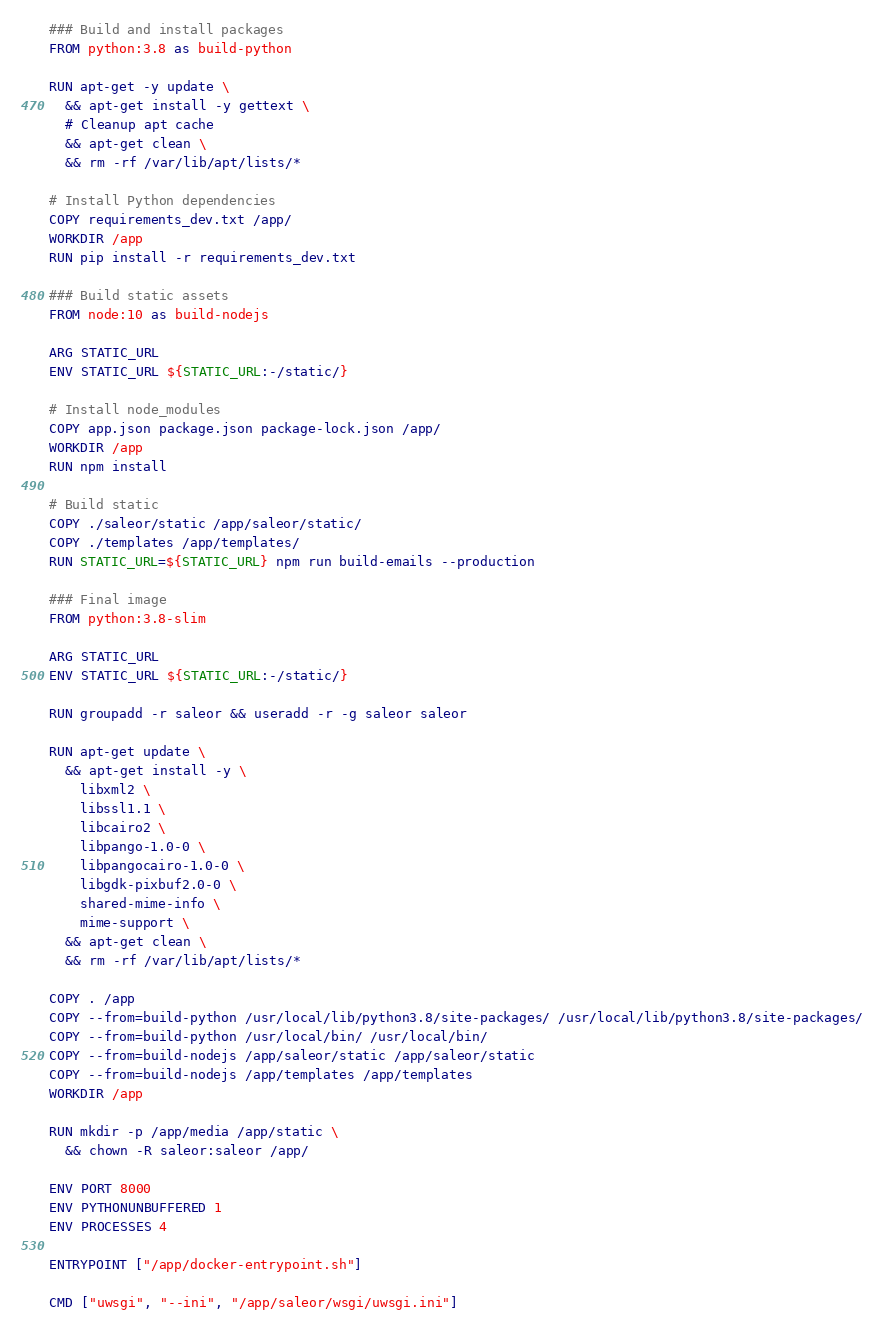<code> <loc_0><loc_0><loc_500><loc_500><_Dockerfile_>### Build and install packages
FROM python:3.8 as build-python

RUN apt-get -y update \
  && apt-get install -y gettext \
  # Cleanup apt cache
  && apt-get clean \
  && rm -rf /var/lib/apt/lists/*

# Install Python dependencies
COPY requirements_dev.txt /app/
WORKDIR /app
RUN pip install -r requirements_dev.txt

### Build static assets
FROM node:10 as build-nodejs

ARG STATIC_URL
ENV STATIC_URL ${STATIC_URL:-/static/}

# Install node_modules
COPY app.json package.json package-lock.json /app/
WORKDIR /app
RUN npm install

# Build static
COPY ./saleor/static /app/saleor/static/
COPY ./templates /app/templates/
RUN STATIC_URL=${STATIC_URL} npm run build-emails --production

### Final image
FROM python:3.8-slim

ARG STATIC_URL
ENV STATIC_URL ${STATIC_URL:-/static/}

RUN groupadd -r saleor && useradd -r -g saleor saleor

RUN apt-get update \
  && apt-get install -y \
    libxml2 \
    libssl1.1 \
    libcairo2 \
    libpango-1.0-0 \
    libpangocairo-1.0-0 \
    libgdk-pixbuf2.0-0 \
    shared-mime-info \
    mime-support \
  && apt-get clean \
  && rm -rf /var/lib/apt/lists/*

COPY . /app
COPY --from=build-python /usr/local/lib/python3.8/site-packages/ /usr/local/lib/python3.8/site-packages/
COPY --from=build-python /usr/local/bin/ /usr/local/bin/
COPY --from=build-nodejs /app/saleor/static /app/saleor/static
COPY --from=build-nodejs /app/templates /app/templates
WORKDIR /app

RUN mkdir -p /app/media /app/static \
  && chown -R saleor:saleor /app/

ENV PORT 8000
ENV PYTHONUNBUFFERED 1
ENV PROCESSES 4

ENTRYPOINT ["/app/docker-entrypoint.sh"]

CMD ["uwsgi", "--ini", "/app/saleor/wsgi/uwsgi.ini"]
</code> 